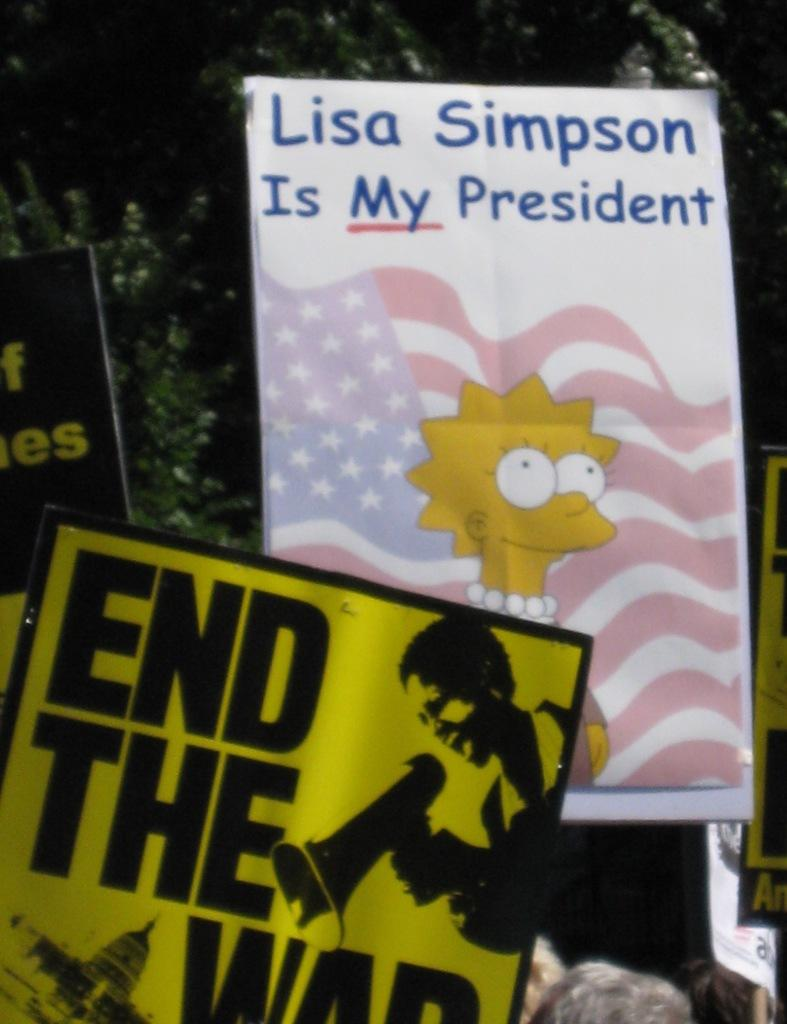What objects are present in the image? There are boards in the image. What can be observed about the appearance of the boards? The boards have multiple colors. What can be seen in the background of the image? There are trees in the background of the image. What is the color of the trees in the image? The trees are green in color. How many fairies are sitting on the green trees in the image? There are no fairies present in the image; it only features boards and trees. 